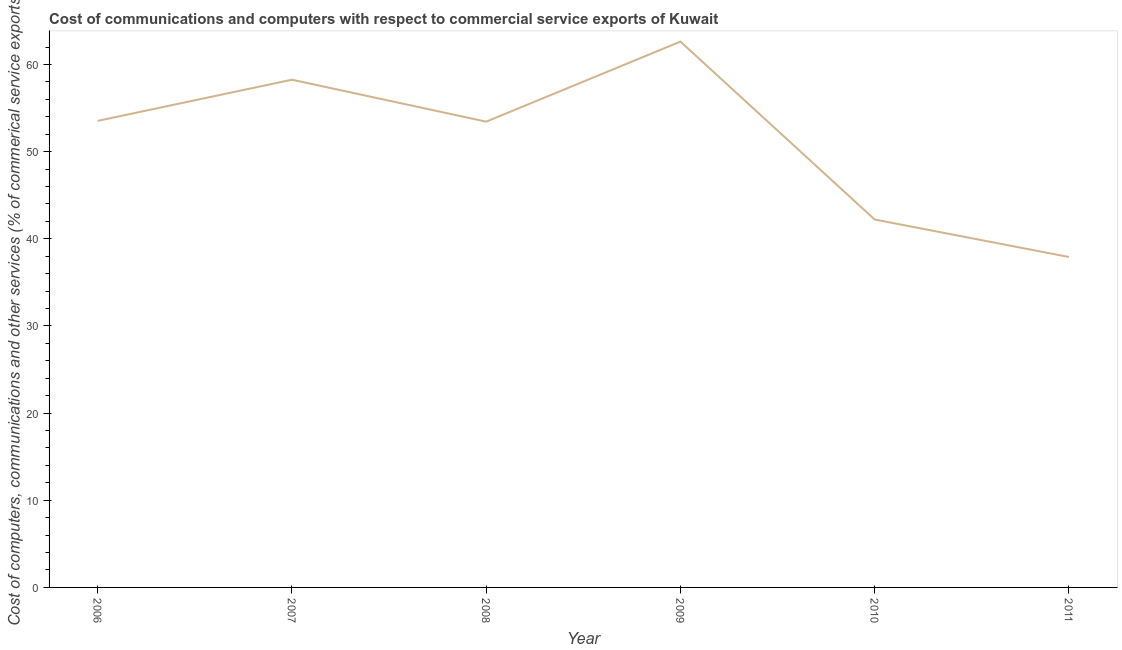What is the  computer and other services in 2011?
Your answer should be very brief. 37.92. Across all years, what is the maximum  computer and other services?
Give a very brief answer. 62.63. Across all years, what is the minimum cost of communications?
Ensure brevity in your answer.  37.92. In which year was the cost of communications minimum?
Make the answer very short. 2011. What is the sum of the  computer and other services?
Keep it short and to the point. 308. What is the difference between the  computer and other services in 2007 and 2008?
Keep it short and to the point. 4.81. What is the average  computer and other services per year?
Provide a short and direct response. 51.33. What is the median  computer and other services?
Ensure brevity in your answer.  53.49. Do a majority of the years between 2010 and 2006 (inclusive) have cost of communications greater than 58 %?
Ensure brevity in your answer.  Yes. What is the ratio of the  computer and other services in 2009 to that in 2010?
Offer a very short reply. 1.48. Is the  computer and other services in 2008 less than that in 2009?
Provide a short and direct response. Yes. What is the difference between the highest and the second highest cost of communications?
Give a very brief answer. 4.37. Is the sum of the  computer and other services in 2007 and 2011 greater than the maximum  computer and other services across all years?
Give a very brief answer. Yes. What is the difference between the highest and the lowest cost of communications?
Give a very brief answer. 24.72. In how many years, is the cost of communications greater than the average cost of communications taken over all years?
Provide a succinct answer. 4. Does the cost of communications monotonically increase over the years?
Provide a short and direct response. No. How many lines are there?
Your answer should be very brief. 1. Does the graph contain grids?
Your answer should be very brief. No. What is the title of the graph?
Ensure brevity in your answer.  Cost of communications and computers with respect to commercial service exports of Kuwait. What is the label or title of the X-axis?
Your response must be concise. Year. What is the label or title of the Y-axis?
Provide a short and direct response. Cost of computers, communications and other services (% of commerical service exports). What is the Cost of computers, communications and other services (% of commerical service exports) in 2006?
Give a very brief answer. 53.54. What is the Cost of computers, communications and other services (% of commerical service exports) in 2007?
Ensure brevity in your answer.  58.26. What is the Cost of computers, communications and other services (% of commerical service exports) of 2008?
Your response must be concise. 53.44. What is the Cost of computers, communications and other services (% of commerical service exports) of 2009?
Offer a very short reply. 62.63. What is the Cost of computers, communications and other services (% of commerical service exports) of 2010?
Your response must be concise. 42.22. What is the Cost of computers, communications and other services (% of commerical service exports) of 2011?
Offer a terse response. 37.92. What is the difference between the Cost of computers, communications and other services (% of commerical service exports) in 2006 and 2007?
Provide a succinct answer. -4.72. What is the difference between the Cost of computers, communications and other services (% of commerical service exports) in 2006 and 2008?
Your response must be concise. 0.09. What is the difference between the Cost of computers, communications and other services (% of commerical service exports) in 2006 and 2009?
Your response must be concise. -9.1. What is the difference between the Cost of computers, communications and other services (% of commerical service exports) in 2006 and 2010?
Offer a very short reply. 11.32. What is the difference between the Cost of computers, communications and other services (% of commerical service exports) in 2006 and 2011?
Offer a very short reply. 15.62. What is the difference between the Cost of computers, communications and other services (% of commerical service exports) in 2007 and 2008?
Your answer should be very brief. 4.81. What is the difference between the Cost of computers, communications and other services (% of commerical service exports) in 2007 and 2009?
Your answer should be compact. -4.37. What is the difference between the Cost of computers, communications and other services (% of commerical service exports) in 2007 and 2010?
Your response must be concise. 16.04. What is the difference between the Cost of computers, communications and other services (% of commerical service exports) in 2007 and 2011?
Ensure brevity in your answer.  20.34. What is the difference between the Cost of computers, communications and other services (% of commerical service exports) in 2008 and 2009?
Give a very brief answer. -9.19. What is the difference between the Cost of computers, communications and other services (% of commerical service exports) in 2008 and 2010?
Your response must be concise. 11.23. What is the difference between the Cost of computers, communications and other services (% of commerical service exports) in 2008 and 2011?
Provide a short and direct response. 15.53. What is the difference between the Cost of computers, communications and other services (% of commerical service exports) in 2009 and 2010?
Ensure brevity in your answer.  20.42. What is the difference between the Cost of computers, communications and other services (% of commerical service exports) in 2009 and 2011?
Give a very brief answer. 24.72. What is the difference between the Cost of computers, communications and other services (% of commerical service exports) in 2010 and 2011?
Ensure brevity in your answer.  4.3. What is the ratio of the Cost of computers, communications and other services (% of commerical service exports) in 2006 to that in 2007?
Offer a very short reply. 0.92. What is the ratio of the Cost of computers, communications and other services (% of commerical service exports) in 2006 to that in 2008?
Give a very brief answer. 1. What is the ratio of the Cost of computers, communications and other services (% of commerical service exports) in 2006 to that in 2009?
Make the answer very short. 0.85. What is the ratio of the Cost of computers, communications and other services (% of commerical service exports) in 2006 to that in 2010?
Offer a terse response. 1.27. What is the ratio of the Cost of computers, communications and other services (% of commerical service exports) in 2006 to that in 2011?
Provide a succinct answer. 1.41. What is the ratio of the Cost of computers, communications and other services (% of commerical service exports) in 2007 to that in 2008?
Ensure brevity in your answer.  1.09. What is the ratio of the Cost of computers, communications and other services (% of commerical service exports) in 2007 to that in 2009?
Offer a terse response. 0.93. What is the ratio of the Cost of computers, communications and other services (% of commerical service exports) in 2007 to that in 2010?
Your response must be concise. 1.38. What is the ratio of the Cost of computers, communications and other services (% of commerical service exports) in 2007 to that in 2011?
Offer a very short reply. 1.54. What is the ratio of the Cost of computers, communications and other services (% of commerical service exports) in 2008 to that in 2009?
Provide a succinct answer. 0.85. What is the ratio of the Cost of computers, communications and other services (% of commerical service exports) in 2008 to that in 2010?
Keep it short and to the point. 1.27. What is the ratio of the Cost of computers, communications and other services (% of commerical service exports) in 2008 to that in 2011?
Give a very brief answer. 1.41. What is the ratio of the Cost of computers, communications and other services (% of commerical service exports) in 2009 to that in 2010?
Your response must be concise. 1.48. What is the ratio of the Cost of computers, communications and other services (% of commerical service exports) in 2009 to that in 2011?
Give a very brief answer. 1.65. What is the ratio of the Cost of computers, communications and other services (% of commerical service exports) in 2010 to that in 2011?
Provide a succinct answer. 1.11. 